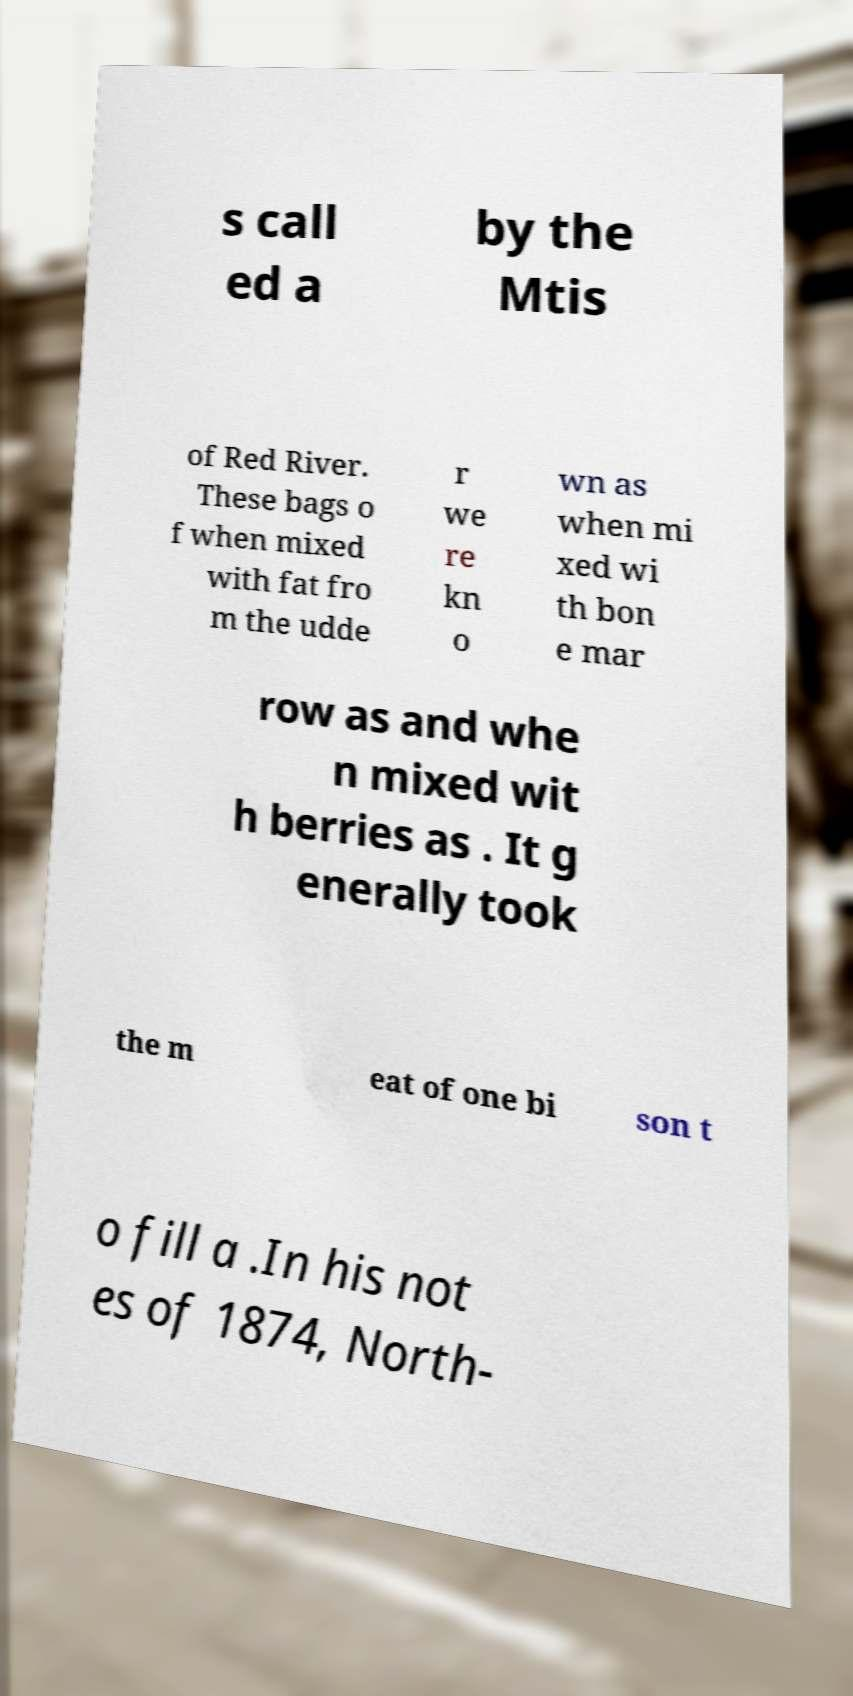For documentation purposes, I need the text within this image transcribed. Could you provide that? s call ed a by the Mtis of Red River. These bags o f when mixed with fat fro m the udde r we re kn o wn as when mi xed wi th bon e mar row as and whe n mixed wit h berries as . It g enerally took the m eat of one bi son t o fill a .In his not es of 1874, North- 